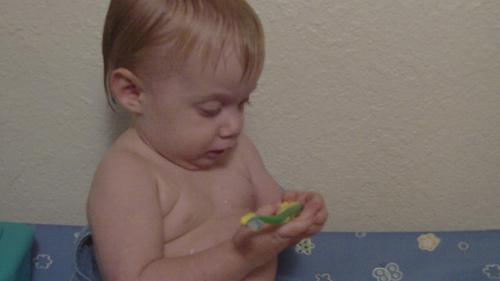How many people are in the photo?
Give a very brief answer. 1. 